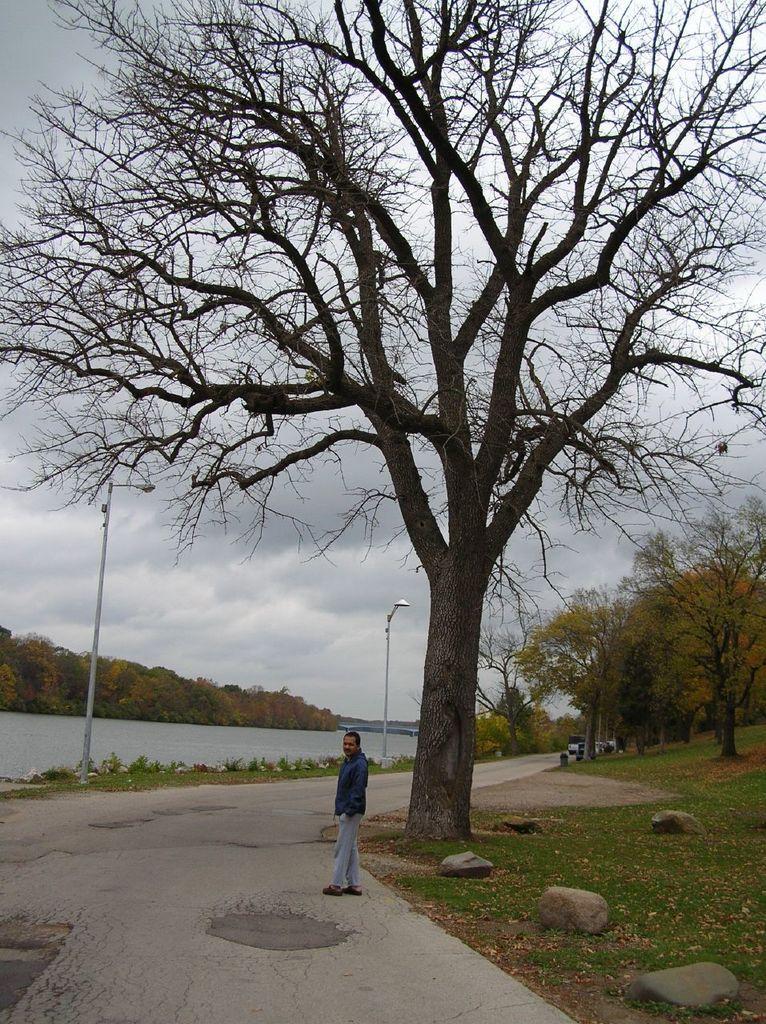Please provide a concise description of this image. In this image there is person standing on a road, on the left side there is a river poles in the background there are trees, on the right side there are trees and cloudy sky. 